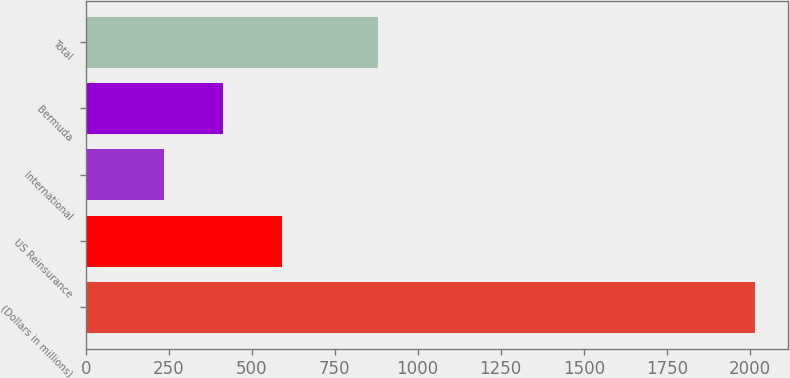<chart> <loc_0><loc_0><loc_500><loc_500><bar_chart><fcel>(Dollars in millions)<fcel>US Reinsurance<fcel>International<fcel>Bermuda<fcel>Total<nl><fcel>2016<fcel>591.52<fcel>235.4<fcel>413.46<fcel>879.3<nl></chart> 